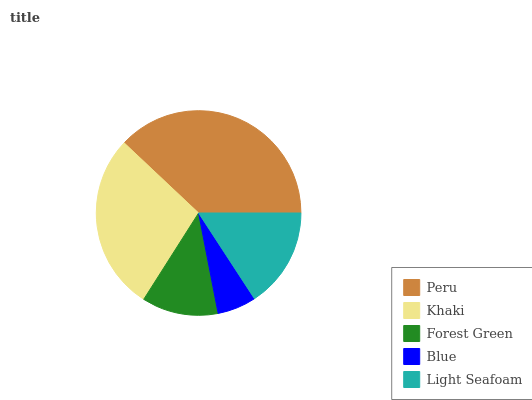Is Blue the minimum?
Answer yes or no. Yes. Is Peru the maximum?
Answer yes or no. Yes. Is Khaki the minimum?
Answer yes or no. No. Is Khaki the maximum?
Answer yes or no. No. Is Peru greater than Khaki?
Answer yes or no. Yes. Is Khaki less than Peru?
Answer yes or no. Yes. Is Khaki greater than Peru?
Answer yes or no. No. Is Peru less than Khaki?
Answer yes or no. No. Is Light Seafoam the high median?
Answer yes or no. Yes. Is Light Seafoam the low median?
Answer yes or no. Yes. Is Khaki the high median?
Answer yes or no. No. Is Forest Green the low median?
Answer yes or no. No. 